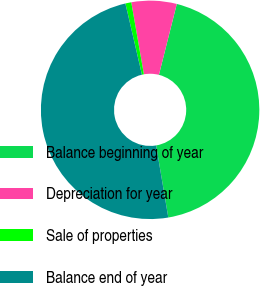Convert chart. <chart><loc_0><loc_0><loc_500><loc_500><pie_chart><fcel>Balance beginning of year<fcel>Depreciation for year<fcel>Sale of properties<fcel>Balance end of year<nl><fcel>43.41%<fcel>6.69%<fcel>0.87%<fcel>49.03%<nl></chart> 